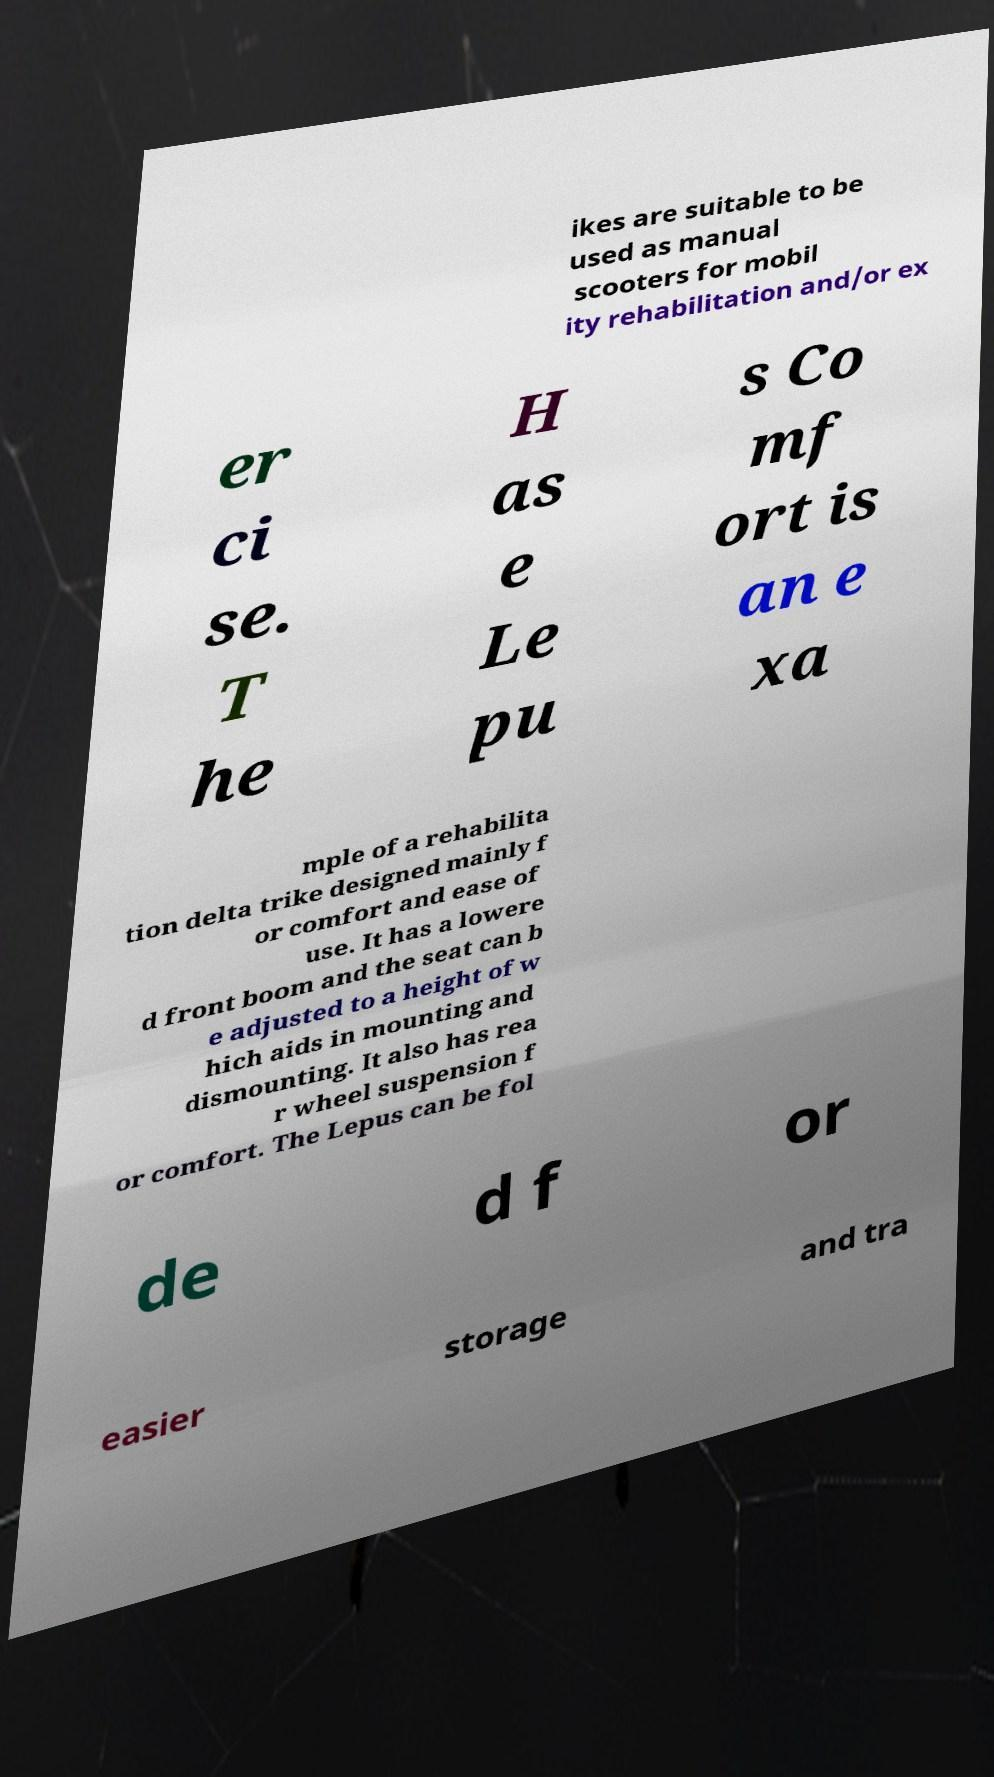Can you accurately transcribe the text from the provided image for me? ikes are suitable to be used as manual scooters for mobil ity rehabilitation and/or ex er ci se. T he H as e Le pu s Co mf ort is an e xa mple of a rehabilita tion delta trike designed mainly f or comfort and ease of use. It has a lowere d front boom and the seat can b e adjusted to a height of w hich aids in mounting and dismounting. It also has rea r wheel suspension f or comfort. The Lepus can be fol de d f or easier storage and tra 